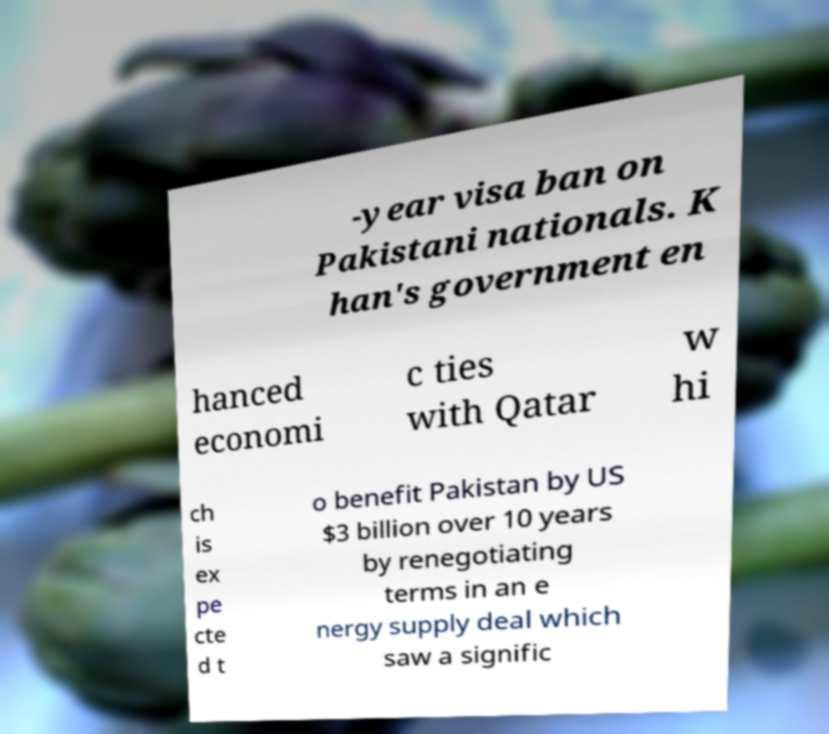Can you accurately transcribe the text from the provided image for me? -year visa ban on Pakistani nationals. K han's government en hanced economi c ties with Qatar w hi ch is ex pe cte d t o benefit Pakistan by US $3 billion over 10 years by renegotiating terms in an e nergy supply deal which saw a signific 